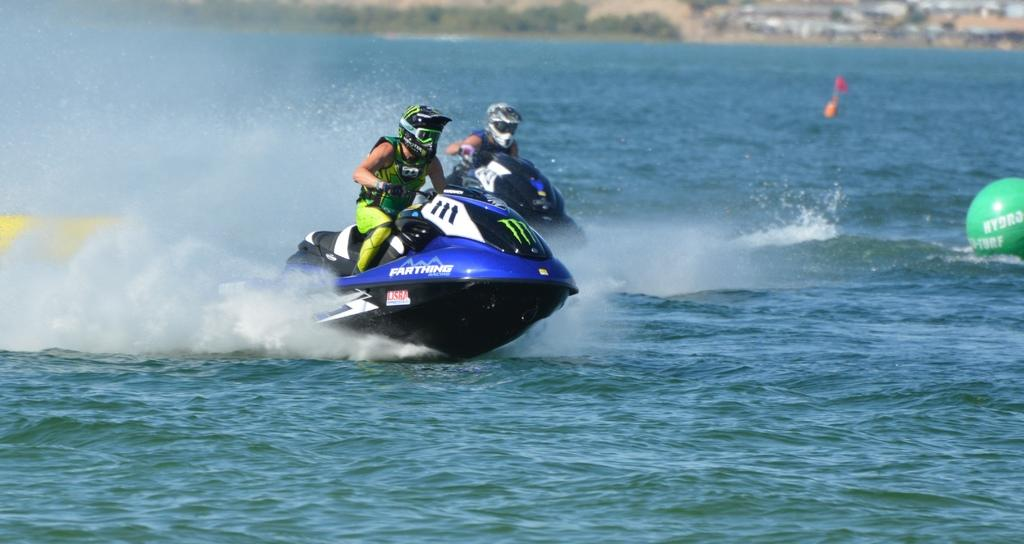What type of vehicles are in the image? There are two speed boats in the image. Where are the speed boats located? The speed boats are in the ocean. What substance is the speed boats made of in the image? The provided facts do not mention the material the speed boats are made of, so we cannot determine the substance they are made of from the image. 